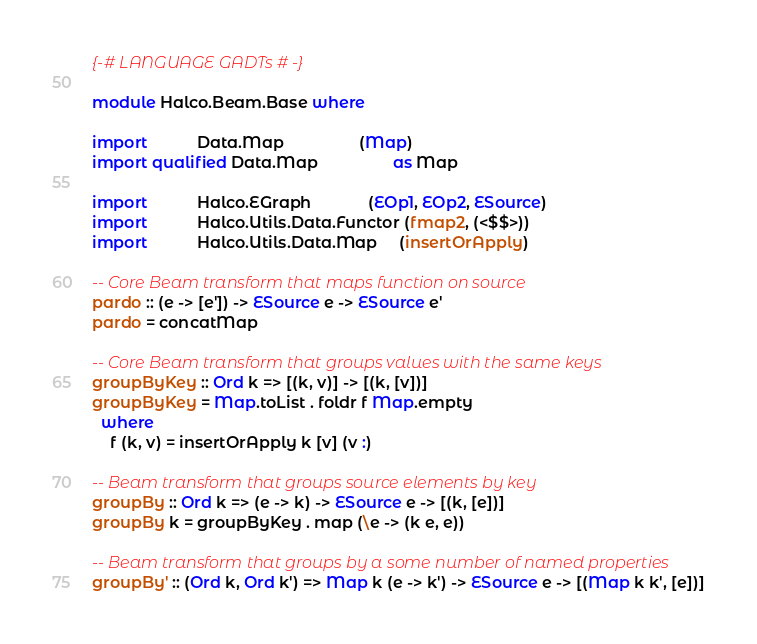Convert code to text. <code><loc_0><loc_0><loc_500><loc_500><_Haskell_>{-# LANGUAGE GADTs #-}

module Halco.Beam.Base where

import           Data.Map                 (Map)
import qualified Data.Map                 as Map

import           Halco.EGraph             (EOp1, EOp2, ESource)
import           Halco.Utils.Data.Functor (fmap2, (<$$>))
import           Halco.Utils.Data.Map     (insertOrApply)

-- Core Beam transform that maps function on source
pardo :: (e -> [e']) -> ESource e -> ESource e'
pardo = concatMap

-- Core Beam transform that groups values with the same keys
groupByKey :: Ord k => [(k, v)] -> [(k, [v])]
groupByKey = Map.toList . foldr f Map.empty
  where
    f (k, v) = insertOrApply k [v] (v :)

-- Beam transform that groups source elements by key
groupBy :: Ord k => (e -> k) -> ESource e -> [(k, [e])]
groupBy k = groupByKey . map (\e -> (k e, e))

-- Beam transform that groups by a some number of named properties
groupBy' :: (Ord k, Ord k') => Map k (e -> k') -> ESource e -> [(Map k k', [e])]</code> 